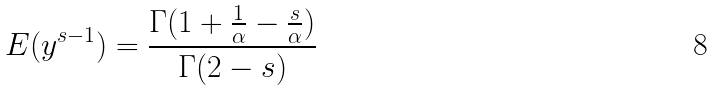Convert formula to latex. <formula><loc_0><loc_0><loc_500><loc_500>E ( y ^ { s - 1 } ) = \frac { \Gamma ( 1 + \frac { 1 } { \alpha } - \frac { s } { \alpha } ) } { \Gamma ( 2 - s ) }</formula> 